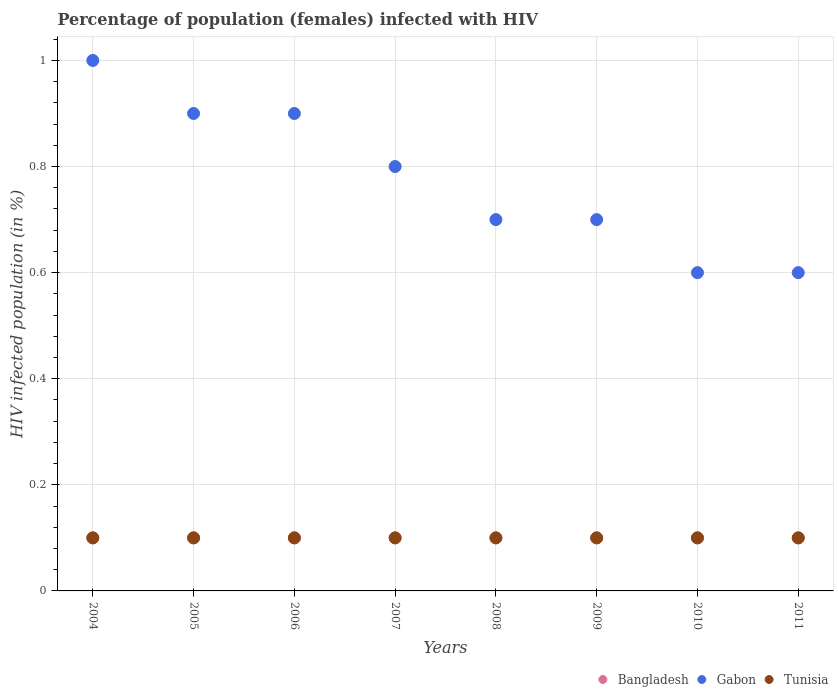How many different coloured dotlines are there?
Keep it short and to the point. 3. Is the number of dotlines equal to the number of legend labels?
Make the answer very short. Yes. What is the percentage of HIV infected female population in Gabon in 2008?
Your answer should be very brief. 0.7. Across all years, what is the maximum percentage of HIV infected female population in Gabon?
Your response must be concise. 1. Across all years, what is the minimum percentage of HIV infected female population in Tunisia?
Provide a succinct answer. 0.1. In which year was the percentage of HIV infected female population in Tunisia maximum?
Offer a very short reply. 2004. What is the total percentage of HIV infected female population in Gabon in the graph?
Your answer should be very brief. 6.2. What is the difference between the percentage of HIV infected female population in Tunisia in 2009 and that in 2011?
Ensure brevity in your answer.  0. What is the difference between the percentage of HIV infected female population in Bangladesh in 2011 and the percentage of HIV infected female population in Gabon in 2007?
Keep it short and to the point. -0.7. In the year 2006, what is the difference between the percentage of HIV infected female population in Bangladesh and percentage of HIV infected female population in Gabon?
Offer a terse response. -0.8. What is the ratio of the percentage of HIV infected female population in Bangladesh in 2006 to that in 2011?
Offer a terse response. 1. Is the percentage of HIV infected female population in Tunisia in 2005 less than that in 2006?
Provide a short and direct response. No. What is the difference between the highest and the second highest percentage of HIV infected female population in Gabon?
Offer a very short reply. 0.1. In how many years, is the percentage of HIV infected female population in Bangladesh greater than the average percentage of HIV infected female population in Bangladesh taken over all years?
Give a very brief answer. 0. Is it the case that in every year, the sum of the percentage of HIV infected female population in Gabon and percentage of HIV infected female population in Bangladesh  is greater than the percentage of HIV infected female population in Tunisia?
Give a very brief answer. Yes. How many years are there in the graph?
Offer a terse response. 8. Are the values on the major ticks of Y-axis written in scientific E-notation?
Your answer should be compact. No. Does the graph contain grids?
Offer a terse response. Yes. What is the title of the graph?
Your answer should be compact. Percentage of population (females) infected with HIV. Does "Netherlands" appear as one of the legend labels in the graph?
Offer a very short reply. No. What is the label or title of the Y-axis?
Make the answer very short. HIV infected population (in %). What is the HIV infected population (in %) in Bangladesh in 2004?
Your answer should be compact. 0.1. What is the HIV infected population (in %) in Gabon in 2004?
Your answer should be very brief. 1. What is the HIV infected population (in %) in Bangladesh in 2005?
Your answer should be very brief. 0.1. What is the HIV infected population (in %) of Gabon in 2005?
Provide a succinct answer. 0.9. What is the HIV infected population (in %) of Bangladesh in 2006?
Provide a short and direct response. 0.1. What is the HIV infected population (in %) of Gabon in 2006?
Keep it short and to the point. 0.9. What is the HIV infected population (in %) of Gabon in 2007?
Your answer should be compact. 0.8. What is the HIV infected population (in %) of Tunisia in 2007?
Offer a very short reply. 0.1. What is the HIV infected population (in %) in Bangladesh in 2009?
Offer a very short reply. 0.1. What is the HIV infected population (in %) in Gabon in 2009?
Give a very brief answer. 0.7. What is the HIV infected population (in %) in Tunisia in 2009?
Make the answer very short. 0.1. What is the HIV infected population (in %) of Gabon in 2011?
Provide a succinct answer. 0.6. What is the HIV infected population (in %) of Tunisia in 2011?
Give a very brief answer. 0.1. Across all years, what is the maximum HIV infected population (in %) in Tunisia?
Give a very brief answer. 0.1. Across all years, what is the minimum HIV infected population (in %) in Bangladesh?
Offer a very short reply. 0.1. Across all years, what is the minimum HIV infected population (in %) of Tunisia?
Keep it short and to the point. 0.1. What is the difference between the HIV infected population (in %) in Bangladesh in 2004 and that in 2005?
Keep it short and to the point. 0. What is the difference between the HIV infected population (in %) in Gabon in 2004 and that in 2005?
Make the answer very short. 0.1. What is the difference between the HIV infected population (in %) in Gabon in 2004 and that in 2006?
Your response must be concise. 0.1. What is the difference between the HIV infected population (in %) of Bangladesh in 2004 and that in 2007?
Provide a succinct answer. 0. What is the difference between the HIV infected population (in %) in Gabon in 2004 and that in 2007?
Offer a terse response. 0.2. What is the difference between the HIV infected population (in %) in Tunisia in 2004 and that in 2007?
Keep it short and to the point. 0. What is the difference between the HIV infected population (in %) of Bangladesh in 2004 and that in 2008?
Ensure brevity in your answer.  0. What is the difference between the HIV infected population (in %) of Bangladesh in 2004 and that in 2009?
Your answer should be very brief. 0. What is the difference between the HIV infected population (in %) of Gabon in 2004 and that in 2009?
Make the answer very short. 0.3. What is the difference between the HIV infected population (in %) of Gabon in 2004 and that in 2010?
Keep it short and to the point. 0.4. What is the difference between the HIV infected population (in %) of Tunisia in 2004 and that in 2010?
Provide a succinct answer. 0. What is the difference between the HIV infected population (in %) in Bangladesh in 2004 and that in 2011?
Your response must be concise. 0. What is the difference between the HIV infected population (in %) in Gabon in 2004 and that in 2011?
Provide a short and direct response. 0.4. What is the difference between the HIV infected population (in %) of Bangladesh in 2005 and that in 2006?
Provide a succinct answer. 0. What is the difference between the HIV infected population (in %) in Gabon in 2005 and that in 2006?
Offer a very short reply. 0. What is the difference between the HIV infected population (in %) of Tunisia in 2005 and that in 2006?
Keep it short and to the point. 0. What is the difference between the HIV infected population (in %) in Bangladesh in 2005 and that in 2007?
Your answer should be compact. 0. What is the difference between the HIV infected population (in %) in Tunisia in 2005 and that in 2007?
Make the answer very short. 0. What is the difference between the HIV infected population (in %) of Gabon in 2005 and that in 2009?
Offer a terse response. 0.2. What is the difference between the HIV infected population (in %) in Tunisia in 2005 and that in 2010?
Your answer should be compact. 0. What is the difference between the HIV infected population (in %) of Bangladesh in 2006 and that in 2007?
Offer a very short reply. 0. What is the difference between the HIV infected population (in %) of Tunisia in 2006 and that in 2007?
Provide a succinct answer. 0. What is the difference between the HIV infected population (in %) of Bangladesh in 2006 and that in 2008?
Provide a succinct answer. 0. What is the difference between the HIV infected population (in %) of Gabon in 2006 and that in 2008?
Ensure brevity in your answer.  0.2. What is the difference between the HIV infected population (in %) in Tunisia in 2006 and that in 2008?
Provide a succinct answer. 0. What is the difference between the HIV infected population (in %) in Bangladesh in 2006 and that in 2009?
Provide a succinct answer. 0. What is the difference between the HIV infected population (in %) of Bangladesh in 2006 and that in 2010?
Your response must be concise. 0. What is the difference between the HIV infected population (in %) of Gabon in 2006 and that in 2010?
Offer a very short reply. 0.3. What is the difference between the HIV infected population (in %) in Bangladesh in 2007 and that in 2008?
Your answer should be very brief. 0. What is the difference between the HIV infected population (in %) of Gabon in 2007 and that in 2008?
Offer a very short reply. 0.1. What is the difference between the HIV infected population (in %) of Gabon in 2007 and that in 2009?
Give a very brief answer. 0.1. What is the difference between the HIV infected population (in %) in Tunisia in 2007 and that in 2009?
Ensure brevity in your answer.  0. What is the difference between the HIV infected population (in %) in Bangladesh in 2007 and that in 2010?
Ensure brevity in your answer.  0. What is the difference between the HIV infected population (in %) of Gabon in 2007 and that in 2010?
Provide a short and direct response. 0.2. What is the difference between the HIV infected population (in %) in Bangladesh in 2007 and that in 2011?
Your response must be concise. 0. What is the difference between the HIV infected population (in %) in Gabon in 2008 and that in 2009?
Provide a succinct answer. 0. What is the difference between the HIV infected population (in %) in Bangladesh in 2008 and that in 2010?
Provide a succinct answer. 0. What is the difference between the HIV infected population (in %) of Gabon in 2008 and that in 2010?
Your answer should be compact. 0.1. What is the difference between the HIV infected population (in %) in Tunisia in 2008 and that in 2010?
Make the answer very short. 0. What is the difference between the HIV infected population (in %) of Bangladesh in 2008 and that in 2011?
Your answer should be very brief. 0. What is the difference between the HIV infected population (in %) in Tunisia in 2008 and that in 2011?
Your answer should be very brief. 0. What is the difference between the HIV infected population (in %) of Tunisia in 2009 and that in 2010?
Ensure brevity in your answer.  0. What is the difference between the HIV infected population (in %) of Bangladesh in 2010 and that in 2011?
Your response must be concise. 0. What is the difference between the HIV infected population (in %) of Gabon in 2010 and that in 2011?
Make the answer very short. 0. What is the difference between the HIV infected population (in %) of Bangladesh in 2004 and the HIV infected population (in %) of Gabon in 2006?
Provide a short and direct response. -0.8. What is the difference between the HIV infected population (in %) in Gabon in 2004 and the HIV infected population (in %) in Tunisia in 2006?
Offer a very short reply. 0.9. What is the difference between the HIV infected population (in %) of Bangladesh in 2004 and the HIV infected population (in %) of Tunisia in 2007?
Provide a short and direct response. 0. What is the difference between the HIV infected population (in %) of Gabon in 2004 and the HIV infected population (in %) of Tunisia in 2007?
Your answer should be compact. 0.9. What is the difference between the HIV infected population (in %) of Bangladesh in 2004 and the HIV infected population (in %) of Gabon in 2008?
Keep it short and to the point. -0.6. What is the difference between the HIV infected population (in %) of Bangladesh in 2004 and the HIV infected population (in %) of Tunisia in 2008?
Your answer should be compact. 0. What is the difference between the HIV infected population (in %) in Bangladesh in 2004 and the HIV infected population (in %) in Tunisia in 2009?
Offer a terse response. 0. What is the difference between the HIV infected population (in %) of Bangladesh in 2004 and the HIV infected population (in %) of Gabon in 2010?
Give a very brief answer. -0.5. What is the difference between the HIV infected population (in %) in Gabon in 2004 and the HIV infected population (in %) in Tunisia in 2010?
Provide a succinct answer. 0.9. What is the difference between the HIV infected population (in %) in Bangladesh in 2004 and the HIV infected population (in %) in Gabon in 2011?
Ensure brevity in your answer.  -0.5. What is the difference between the HIV infected population (in %) in Gabon in 2004 and the HIV infected population (in %) in Tunisia in 2011?
Make the answer very short. 0.9. What is the difference between the HIV infected population (in %) of Bangladesh in 2005 and the HIV infected population (in %) of Gabon in 2006?
Provide a succinct answer. -0.8. What is the difference between the HIV infected population (in %) of Gabon in 2005 and the HIV infected population (in %) of Tunisia in 2006?
Offer a terse response. 0.8. What is the difference between the HIV infected population (in %) in Bangladesh in 2005 and the HIV infected population (in %) in Gabon in 2007?
Give a very brief answer. -0.7. What is the difference between the HIV infected population (in %) of Gabon in 2005 and the HIV infected population (in %) of Tunisia in 2007?
Your response must be concise. 0.8. What is the difference between the HIV infected population (in %) in Bangladesh in 2005 and the HIV infected population (in %) in Gabon in 2008?
Provide a short and direct response. -0.6. What is the difference between the HIV infected population (in %) of Bangladesh in 2005 and the HIV infected population (in %) of Tunisia in 2008?
Provide a succinct answer. 0. What is the difference between the HIV infected population (in %) in Gabon in 2005 and the HIV infected population (in %) in Tunisia in 2008?
Provide a succinct answer. 0.8. What is the difference between the HIV infected population (in %) in Bangladesh in 2005 and the HIV infected population (in %) in Gabon in 2009?
Offer a terse response. -0.6. What is the difference between the HIV infected population (in %) in Gabon in 2005 and the HIV infected population (in %) in Tunisia in 2010?
Your answer should be very brief. 0.8. What is the difference between the HIV infected population (in %) of Gabon in 2005 and the HIV infected population (in %) of Tunisia in 2011?
Provide a succinct answer. 0.8. What is the difference between the HIV infected population (in %) of Gabon in 2006 and the HIV infected population (in %) of Tunisia in 2007?
Your answer should be very brief. 0.8. What is the difference between the HIV infected population (in %) in Bangladesh in 2006 and the HIV infected population (in %) in Gabon in 2009?
Make the answer very short. -0.6. What is the difference between the HIV infected population (in %) of Bangladesh in 2006 and the HIV infected population (in %) of Tunisia in 2010?
Give a very brief answer. 0. What is the difference between the HIV infected population (in %) of Bangladesh in 2006 and the HIV infected population (in %) of Tunisia in 2011?
Provide a short and direct response. 0. What is the difference between the HIV infected population (in %) in Gabon in 2006 and the HIV infected population (in %) in Tunisia in 2011?
Offer a terse response. 0.8. What is the difference between the HIV infected population (in %) in Bangladesh in 2007 and the HIV infected population (in %) in Gabon in 2008?
Ensure brevity in your answer.  -0.6. What is the difference between the HIV infected population (in %) in Bangladesh in 2007 and the HIV infected population (in %) in Tunisia in 2009?
Keep it short and to the point. 0. What is the difference between the HIV infected population (in %) of Gabon in 2007 and the HIV infected population (in %) of Tunisia in 2009?
Offer a terse response. 0.7. What is the difference between the HIV infected population (in %) in Bangladesh in 2007 and the HIV infected population (in %) in Tunisia in 2010?
Your response must be concise. 0. What is the difference between the HIV infected population (in %) of Bangladesh in 2008 and the HIV infected population (in %) of Gabon in 2009?
Provide a short and direct response. -0.6. What is the difference between the HIV infected population (in %) in Bangladesh in 2008 and the HIV infected population (in %) in Tunisia in 2010?
Your answer should be compact. 0. What is the difference between the HIV infected population (in %) of Gabon in 2008 and the HIV infected population (in %) of Tunisia in 2010?
Make the answer very short. 0.6. What is the difference between the HIV infected population (in %) in Bangladesh in 2008 and the HIV infected population (in %) in Gabon in 2011?
Ensure brevity in your answer.  -0.5. What is the difference between the HIV infected population (in %) in Bangladesh in 2008 and the HIV infected population (in %) in Tunisia in 2011?
Provide a succinct answer. 0. What is the difference between the HIV infected population (in %) of Gabon in 2008 and the HIV infected population (in %) of Tunisia in 2011?
Your answer should be compact. 0.6. What is the difference between the HIV infected population (in %) of Bangladesh in 2009 and the HIV infected population (in %) of Tunisia in 2011?
Your answer should be compact. 0. What is the difference between the HIV infected population (in %) in Bangladesh in 2010 and the HIV infected population (in %) in Gabon in 2011?
Make the answer very short. -0.5. What is the difference between the HIV infected population (in %) of Bangladesh in 2010 and the HIV infected population (in %) of Tunisia in 2011?
Ensure brevity in your answer.  0. What is the difference between the HIV infected population (in %) in Gabon in 2010 and the HIV infected population (in %) in Tunisia in 2011?
Provide a short and direct response. 0.5. What is the average HIV infected population (in %) in Gabon per year?
Keep it short and to the point. 0.78. In the year 2004, what is the difference between the HIV infected population (in %) of Bangladesh and HIV infected population (in %) of Tunisia?
Provide a succinct answer. 0. In the year 2004, what is the difference between the HIV infected population (in %) in Gabon and HIV infected population (in %) in Tunisia?
Give a very brief answer. 0.9. In the year 2005, what is the difference between the HIV infected population (in %) of Bangladesh and HIV infected population (in %) of Gabon?
Your answer should be compact. -0.8. In the year 2005, what is the difference between the HIV infected population (in %) of Bangladesh and HIV infected population (in %) of Tunisia?
Your answer should be compact. 0. In the year 2005, what is the difference between the HIV infected population (in %) of Gabon and HIV infected population (in %) of Tunisia?
Make the answer very short. 0.8. In the year 2006, what is the difference between the HIV infected population (in %) of Bangladesh and HIV infected population (in %) of Gabon?
Provide a short and direct response. -0.8. In the year 2006, what is the difference between the HIV infected population (in %) in Bangladesh and HIV infected population (in %) in Tunisia?
Offer a very short reply. 0. In the year 2007, what is the difference between the HIV infected population (in %) in Bangladesh and HIV infected population (in %) in Gabon?
Your answer should be compact. -0.7. In the year 2007, what is the difference between the HIV infected population (in %) of Bangladesh and HIV infected population (in %) of Tunisia?
Provide a succinct answer. 0. In the year 2007, what is the difference between the HIV infected population (in %) of Gabon and HIV infected population (in %) of Tunisia?
Provide a short and direct response. 0.7. In the year 2008, what is the difference between the HIV infected population (in %) in Bangladesh and HIV infected population (in %) in Tunisia?
Offer a terse response. 0. In the year 2009, what is the difference between the HIV infected population (in %) in Bangladesh and HIV infected population (in %) in Gabon?
Provide a short and direct response. -0.6. In the year 2010, what is the difference between the HIV infected population (in %) in Bangladesh and HIV infected population (in %) in Tunisia?
Provide a succinct answer. 0. In the year 2010, what is the difference between the HIV infected population (in %) in Gabon and HIV infected population (in %) in Tunisia?
Your answer should be compact. 0.5. In the year 2011, what is the difference between the HIV infected population (in %) in Bangladesh and HIV infected population (in %) in Tunisia?
Make the answer very short. 0. In the year 2011, what is the difference between the HIV infected population (in %) in Gabon and HIV infected population (in %) in Tunisia?
Provide a succinct answer. 0.5. What is the ratio of the HIV infected population (in %) in Bangladesh in 2004 to that in 2005?
Your answer should be very brief. 1. What is the ratio of the HIV infected population (in %) of Gabon in 2004 to that in 2006?
Give a very brief answer. 1.11. What is the ratio of the HIV infected population (in %) of Tunisia in 2004 to that in 2006?
Your response must be concise. 1. What is the ratio of the HIV infected population (in %) in Bangladesh in 2004 to that in 2007?
Your response must be concise. 1. What is the ratio of the HIV infected population (in %) in Tunisia in 2004 to that in 2007?
Your response must be concise. 1. What is the ratio of the HIV infected population (in %) of Gabon in 2004 to that in 2008?
Offer a very short reply. 1.43. What is the ratio of the HIV infected population (in %) in Bangladesh in 2004 to that in 2009?
Your response must be concise. 1. What is the ratio of the HIV infected population (in %) of Gabon in 2004 to that in 2009?
Ensure brevity in your answer.  1.43. What is the ratio of the HIV infected population (in %) in Tunisia in 2004 to that in 2009?
Make the answer very short. 1. What is the ratio of the HIV infected population (in %) in Bangladesh in 2005 to that in 2007?
Ensure brevity in your answer.  1. What is the ratio of the HIV infected population (in %) in Gabon in 2005 to that in 2008?
Your response must be concise. 1.29. What is the ratio of the HIV infected population (in %) in Tunisia in 2005 to that in 2008?
Your answer should be very brief. 1. What is the ratio of the HIV infected population (in %) in Bangladesh in 2005 to that in 2009?
Give a very brief answer. 1. What is the ratio of the HIV infected population (in %) in Tunisia in 2005 to that in 2009?
Provide a succinct answer. 1. What is the ratio of the HIV infected population (in %) in Gabon in 2005 to that in 2010?
Provide a short and direct response. 1.5. What is the ratio of the HIV infected population (in %) of Tunisia in 2005 to that in 2010?
Your answer should be compact. 1. What is the ratio of the HIV infected population (in %) of Gabon in 2005 to that in 2011?
Your response must be concise. 1.5. What is the ratio of the HIV infected population (in %) of Tunisia in 2005 to that in 2011?
Your answer should be very brief. 1. What is the ratio of the HIV infected population (in %) in Bangladesh in 2006 to that in 2007?
Your response must be concise. 1. What is the ratio of the HIV infected population (in %) of Gabon in 2006 to that in 2007?
Offer a terse response. 1.12. What is the ratio of the HIV infected population (in %) of Tunisia in 2006 to that in 2010?
Keep it short and to the point. 1. What is the ratio of the HIV infected population (in %) of Gabon in 2007 to that in 2008?
Offer a very short reply. 1.14. What is the ratio of the HIV infected population (in %) of Bangladesh in 2007 to that in 2009?
Your answer should be very brief. 1. What is the ratio of the HIV infected population (in %) in Gabon in 2007 to that in 2009?
Give a very brief answer. 1.14. What is the ratio of the HIV infected population (in %) of Bangladesh in 2007 to that in 2010?
Your response must be concise. 1. What is the ratio of the HIV infected population (in %) of Bangladesh in 2007 to that in 2011?
Provide a short and direct response. 1. What is the ratio of the HIV infected population (in %) of Tunisia in 2007 to that in 2011?
Give a very brief answer. 1. What is the ratio of the HIV infected population (in %) in Gabon in 2008 to that in 2009?
Offer a terse response. 1. What is the ratio of the HIV infected population (in %) of Tunisia in 2008 to that in 2009?
Your answer should be very brief. 1. What is the ratio of the HIV infected population (in %) of Gabon in 2008 to that in 2010?
Your answer should be very brief. 1.17. What is the ratio of the HIV infected population (in %) of Bangladesh in 2008 to that in 2011?
Provide a succinct answer. 1. What is the ratio of the HIV infected population (in %) in Bangladesh in 2009 to that in 2010?
Your response must be concise. 1. What is the ratio of the HIV infected population (in %) of Tunisia in 2009 to that in 2011?
Make the answer very short. 1. What is the ratio of the HIV infected population (in %) in Gabon in 2010 to that in 2011?
Your answer should be very brief. 1. What is the ratio of the HIV infected population (in %) of Tunisia in 2010 to that in 2011?
Offer a terse response. 1. What is the difference between the highest and the second highest HIV infected population (in %) in Bangladesh?
Ensure brevity in your answer.  0. What is the difference between the highest and the second highest HIV infected population (in %) of Gabon?
Offer a very short reply. 0.1. What is the difference between the highest and the lowest HIV infected population (in %) of Bangladesh?
Provide a short and direct response. 0. What is the difference between the highest and the lowest HIV infected population (in %) of Tunisia?
Ensure brevity in your answer.  0. 